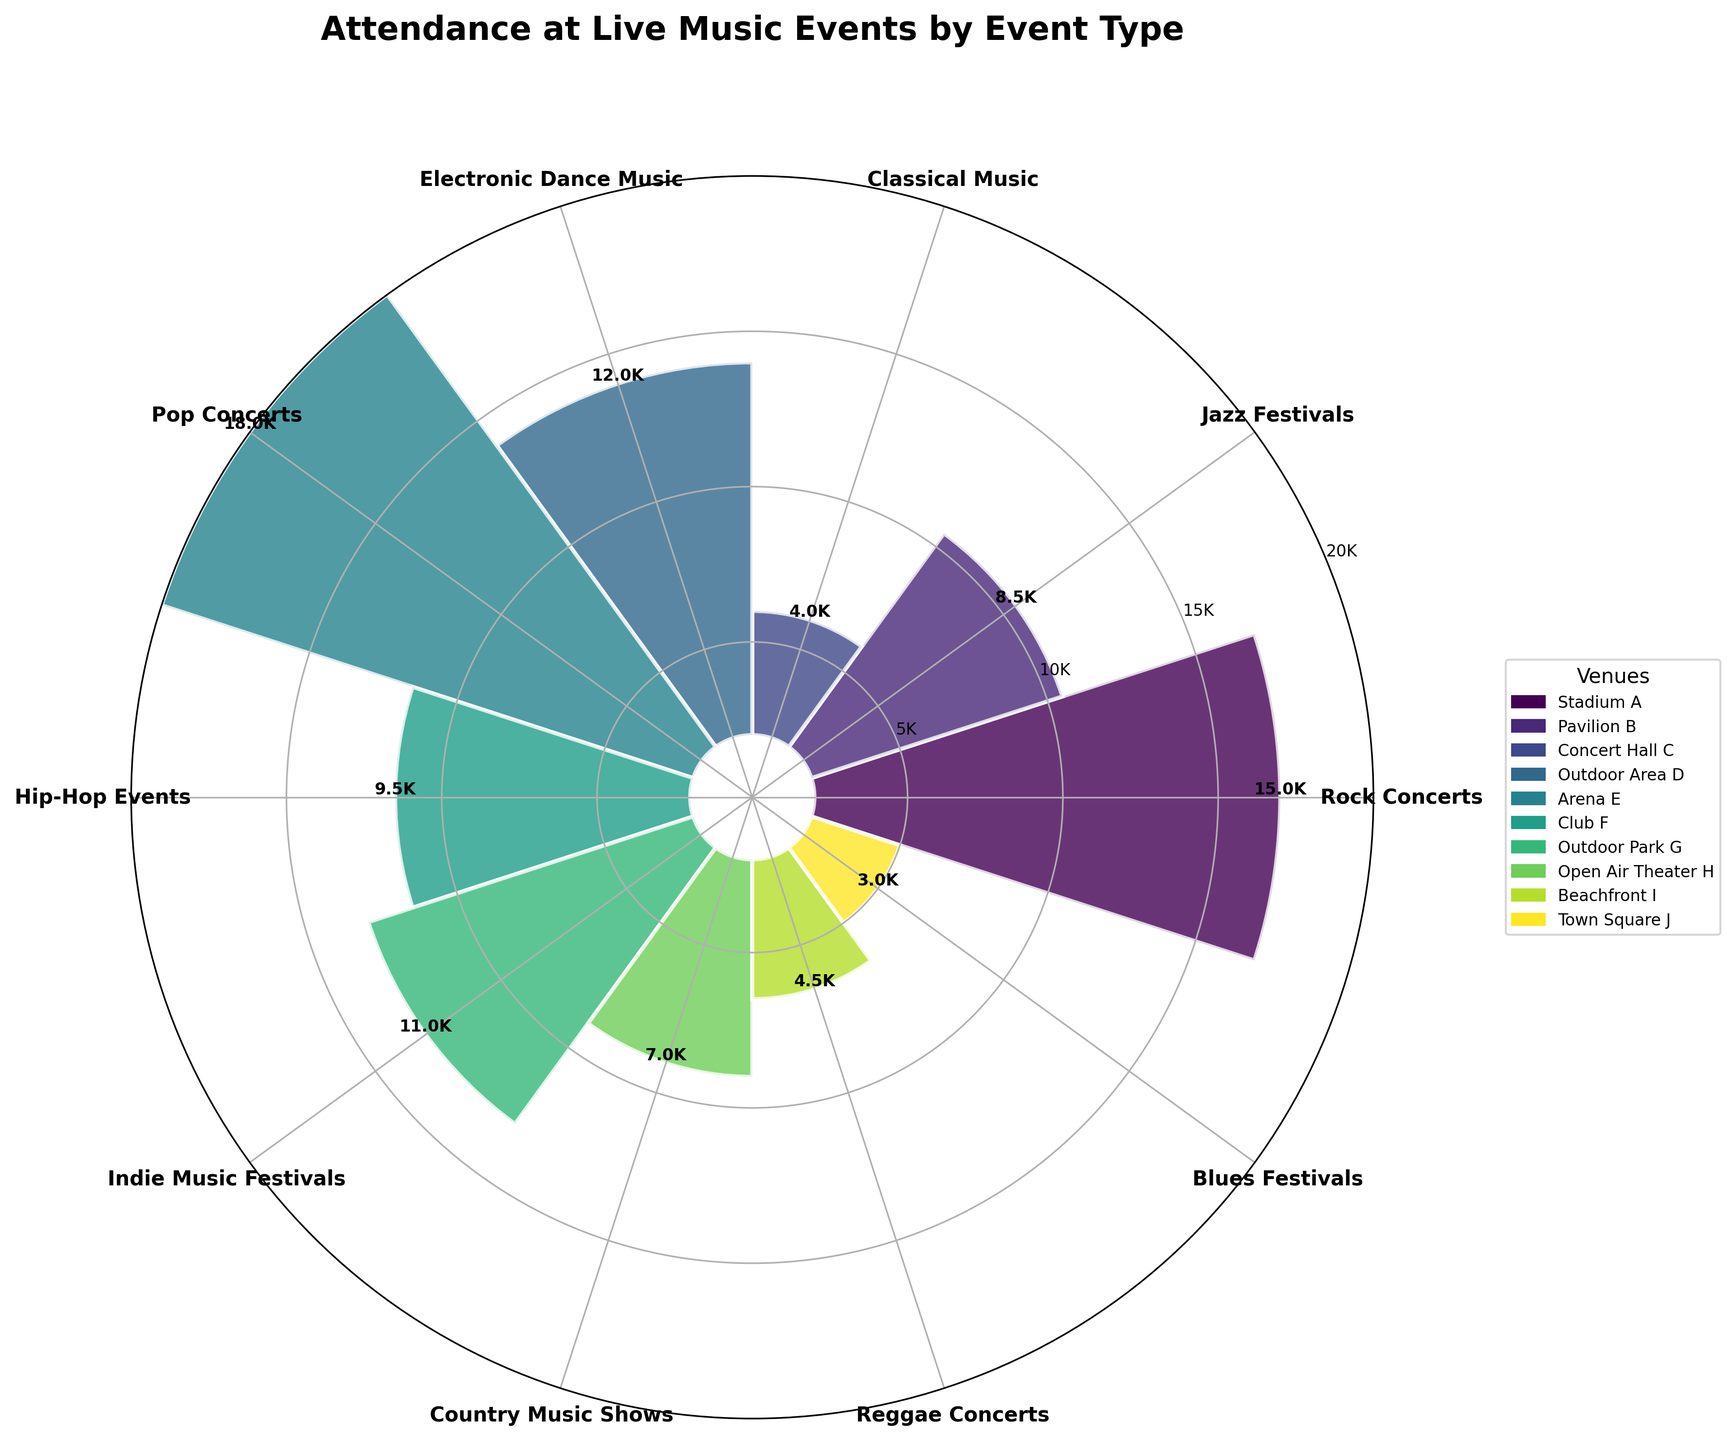How many event types are displayed in the rose chart? The rose chart shows a bar for each event type. By counting the bars or the labels on the axes, we can determine the number of event types.
Answer: 10 Which event type has the highest attendance? To determine this, we can visually inspect the bars and look for the one with the greatest height. The bar representing "Pop Concerts" is the tallest.
Answer: Pop Concerts What is the combined attendance for Rock Concerts and Electronic Dance Music? Add the attendance for Rock Concerts (15,000) and Electronic Dance Music (12,000). 15,000 + 12,000.
Answer: 27,000 Is the attendance for Jazz Festivals greater than for Hip-Hop Events? Compare the heights of the bars for Jazz Festivals (8,500) and Hip-Hop Events (9,500). Since 8,500 is less than 9,500, the attendance for Jazz Festivals is not greater.
Answer: No What is the average attendance across all event types? Add the attendance figures for all event types and divide by the number of events (sum: 15,000 + 8,500 + 4,000 + 12,000 + 18,000 + 9,500 + 11,000 + 7,000 + 4,500 + 3,000 = 92,500). Then divide by 10.
Answer: 9,250 Which venue hosts the Rock Concerts? The chart's legend matches the entities to the colors of the bars. The legend lists "Stadium A" next to the color representing Rock Concerts.
Answer: Stadium A What is the difference in attendance between the highest and lowest attended event types? Identify the highest (Pop Concerts, 18,000) and lowest (Blues Festivals, 3,000) and subtract the latter from the former. 18,000 - 3,000.
Answer: 15,000 Which event type has attendance closest to 10,000? Inspect the bars and find the one closest to 10,000. "Indie Music Festivals" with 11,000 is closest.
Answer: Indie Music Festivals How are the attendance values labeled in the context of the chart's design? The radial axis has attendance markers labeled as "5K", "10K", "15K", and "20K", representing increments of 5,000.
Answer: In increments of 5,000 Are there more event types with attendance above or below 10,000? Count the bars for event types with attendance above 10,000 (Rock Concerts, Electronic Dance Music, Pop Concerts, Indie Music Festivals) and below 10,000 (Jazz Festivals, Classical Music, Hip-Hop Events, Country Music Shows, Reggae Concerts, Blues Festivals). There are 4 above and 6 below.
Answer: Below 